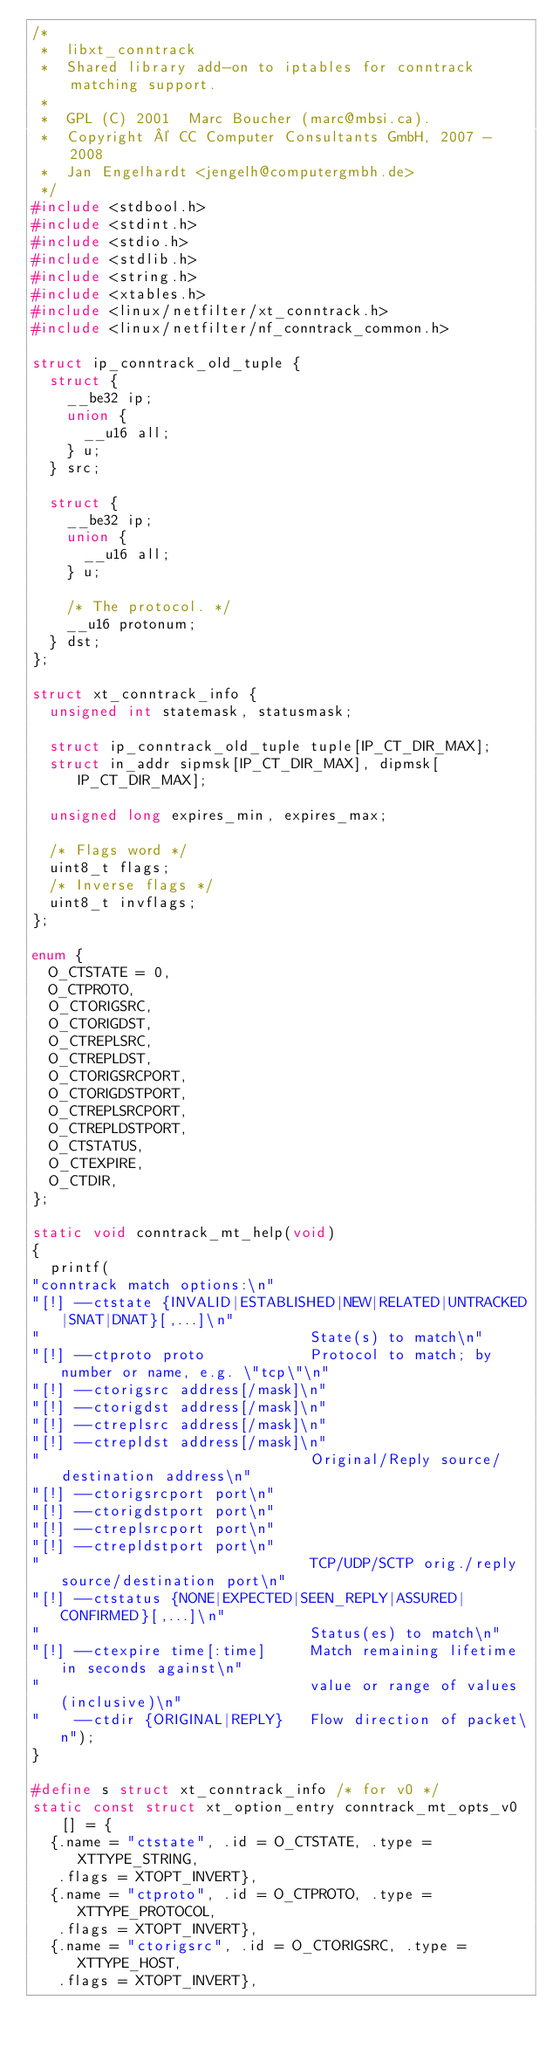Convert code to text. <code><loc_0><loc_0><loc_500><loc_500><_C_>/*
 *	libxt_conntrack
 *	Shared library add-on to iptables for conntrack matching support.
 *
 *	GPL (C) 2001  Marc Boucher (marc@mbsi.ca).
 *	Copyright © CC Computer Consultants GmbH, 2007 - 2008
 *	Jan Engelhardt <jengelh@computergmbh.de>
 */
#include <stdbool.h>
#include <stdint.h>
#include <stdio.h>
#include <stdlib.h>
#include <string.h>
#include <xtables.h>
#include <linux/netfilter/xt_conntrack.h>
#include <linux/netfilter/nf_conntrack_common.h>

struct ip_conntrack_old_tuple {
	struct {
		__be32 ip;
		union {
			__u16 all;
		} u;
	} src;

	struct {
		__be32 ip;
		union {
			__u16 all;
		} u;

		/* The protocol. */
		__u16 protonum;
	} dst;
};

struct xt_conntrack_info {
	unsigned int statemask, statusmask;

	struct ip_conntrack_old_tuple tuple[IP_CT_DIR_MAX];
	struct in_addr sipmsk[IP_CT_DIR_MAX], dipmsk[IP_CT_DIR_MAX];

	unsigned long expires_min, expires_max;

	/* Flags word */
	uint8_t flags;
	/* Inverse flags */
	uint8_t invflags;
};

enum {
	O_CTSTATE = 0,
	O_CTPROTO,
	O_CTORIGSRC,
	O_CTORIGDST,
	O_CTREPLSRC,
	O_CTREPLDST,
	O_CTORIGSRCPORT,
	O_CTORIGDSTPORT,
	O_CTREPLSRCPORT,
	O_CTREPLDSTPORT,
	O_CTSTATUS,
	O_CTEXPIRE,
	O_CTDIR,
};

static void conntrack_mt_help(void)
{
	printf(
"conntrack match options:\n"
"[!] --ctstate {INVALID|ESTABLISHED|NEW|RELATED|UNTRACKED|SNAT|DNAT}[,...]\n"
"                               State(s) to match\n"
"[!] --ctproto proto            Protocol to match; by number or name, e.g. \"tcp\"\n"
"[!] --ctorigsrc address[/mask]\n"
"[!] --ctorigdst address[/mask]\n"
"[!] --ctreplsrc address[/mask]\n"
"[!] --ctrepldst address[/mask]\n"
"                               Original/Reply source/destination address\n"
"[!] --ctorigsrcport port\n"
"[!] --ctorigdstport port\n"
"[!] --ctreplsrcport port\n"
"[!] --ctrepldstport port\n"
"                               TCP/UDP/SCTP orig./reply source/destination port\n"
"[!] --ctstatus {NONE|EXPECTED|SEEN_REPLY|ASSURED|CONFIRMED}[,...]\n"
"                               Status(es) to match\n"
"[!] --ctexpire time[:time]     Match remaining lifetime in seconds against\n"
"                               value or range of values (inclusive)\n"
"    --ctdir {ORIGINAL|REPLY}   Flow direction of packet\n");
}

#define s struct xt_conntrack_info /* for v0 */
static const struct xt_option_entry conntrack_mt_opts_v0[] = {
	{.name = "ctstate", .id = O_CTSTATE, .type = XTTYPE_STRING,
	 .flags = XTOPT_INVERT},
	{.name = "ctproto", .id = O_CTPROTO, .type = XTTYPE_PROTOCOL,
	 .flags = XTOPT_INVERT},
	{.name = "ctorigsrc", .id = O_CTORIGSRC, .type = XTTYPE_HOST,
	 .flags = XTOPT_INVERT},</code> 